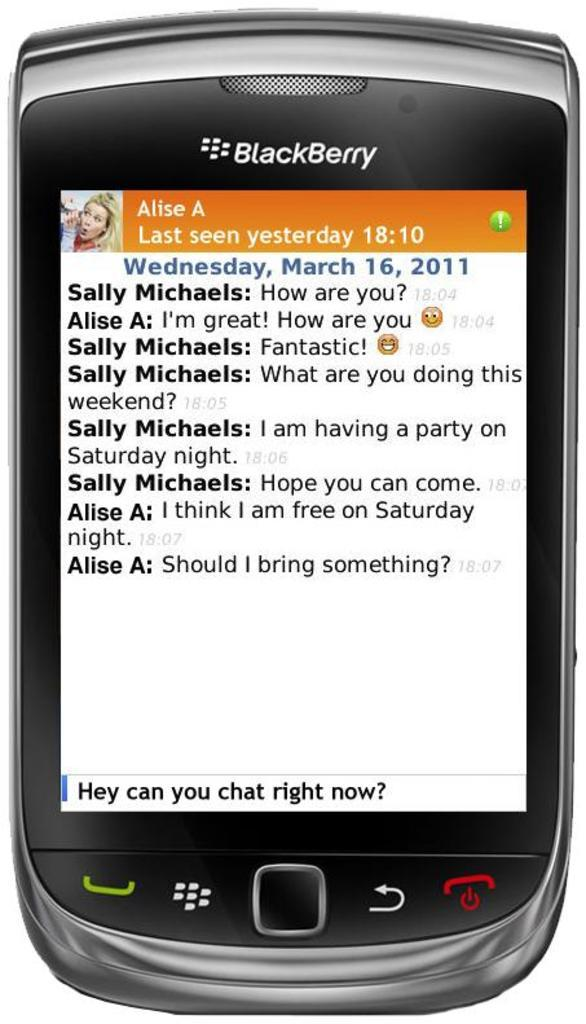Provide a one-sentence caption for the provided image. A BlackBerry is in focus and showing a text conversation about party plans for the weekend. 